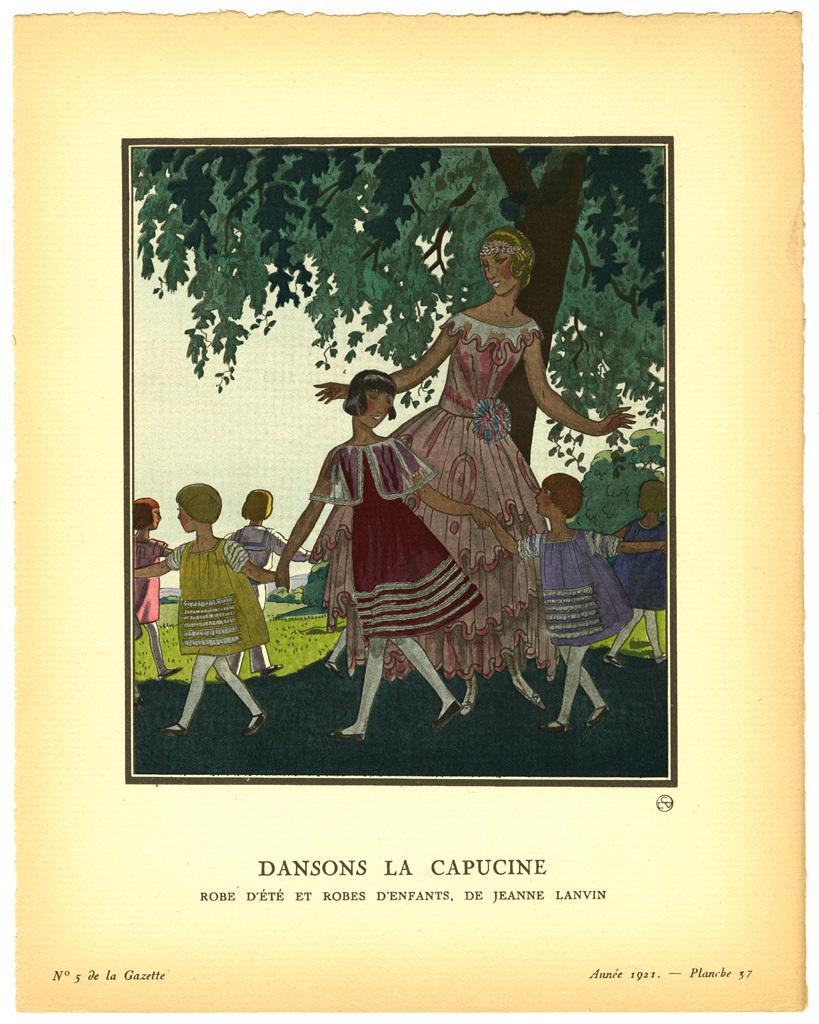Describe this image in one or two sentences. In this image we can see a poster with some text written on it, also we can see images of a few people playing under the tree. 